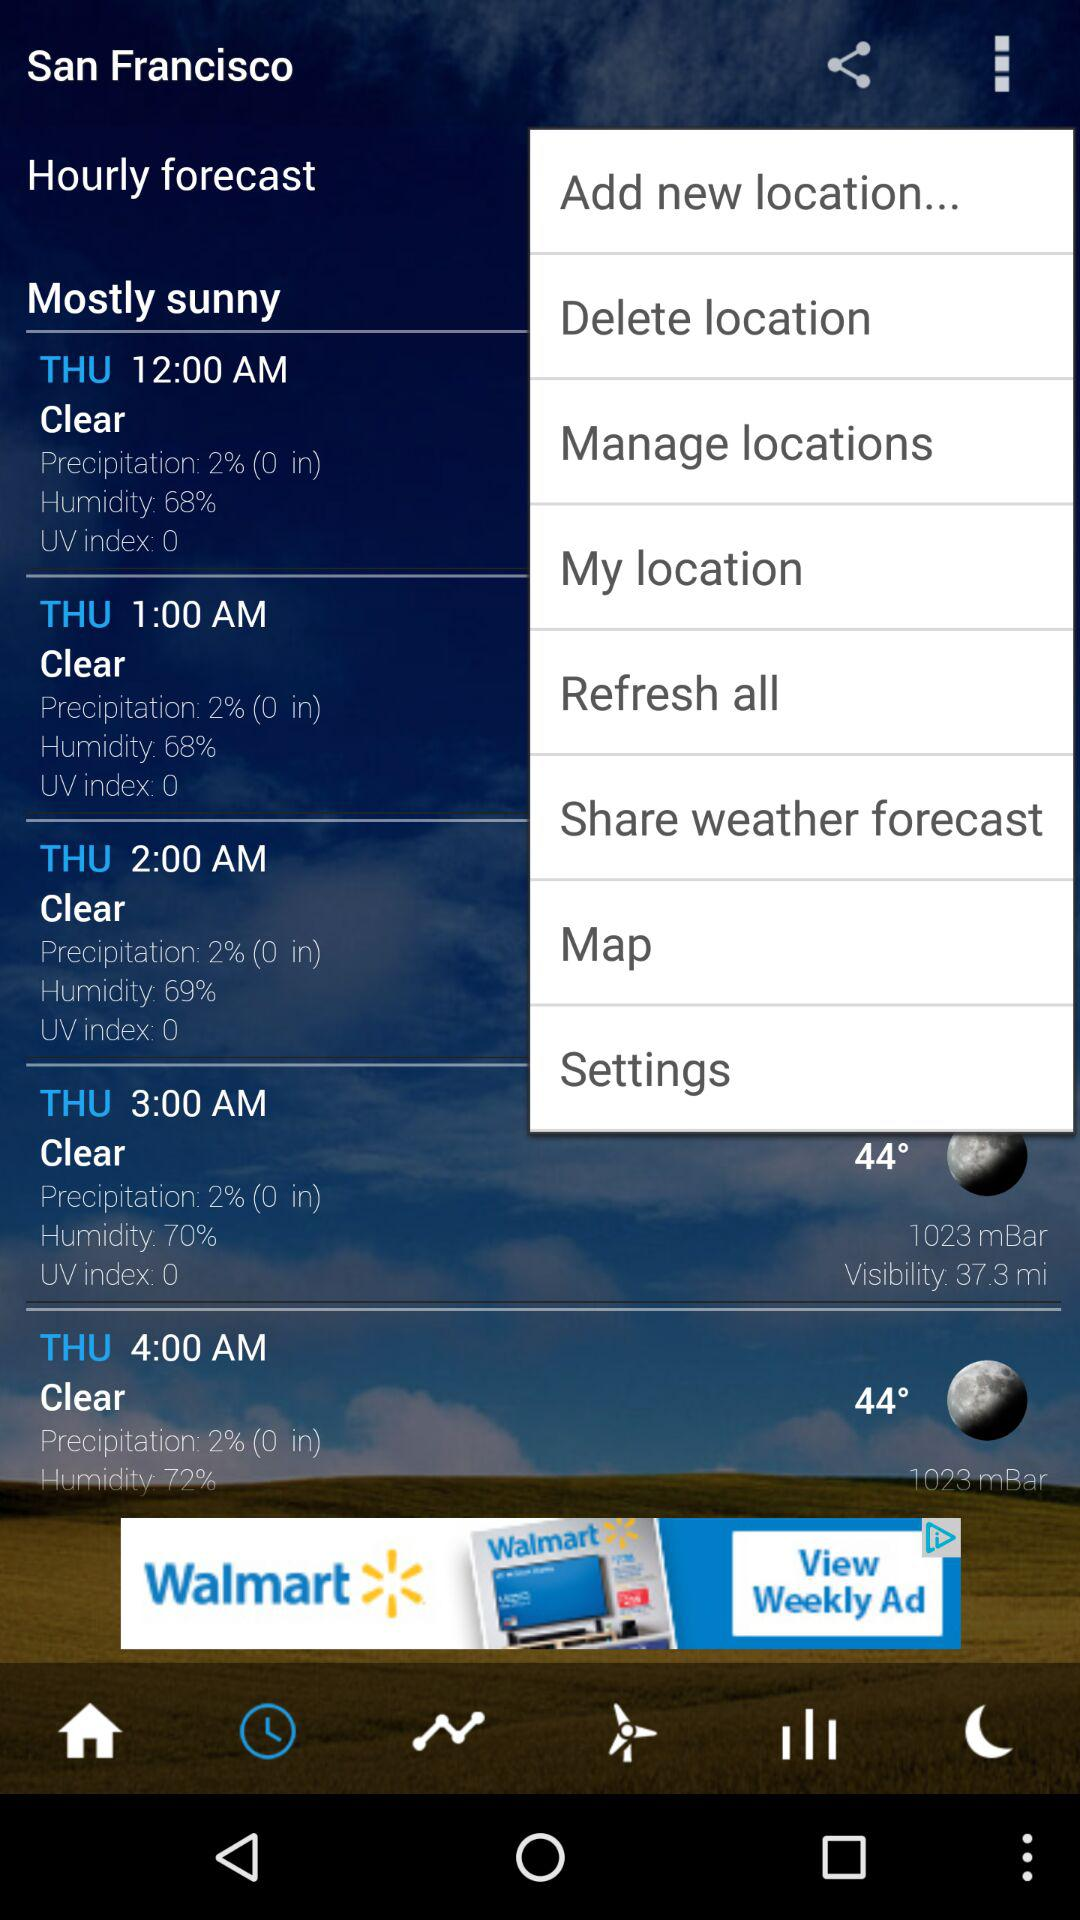What's the visibility at 3 am on Thursday? The visibility is clear. 